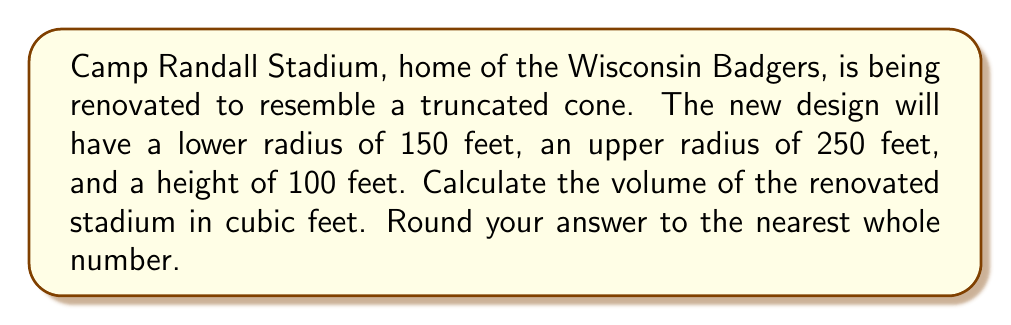Show me your answer to this math problem. To solve this problem, we'll use the formula for the volume of a truncated cone:

$$V = \frac{1}{3}\pi h(R^2 + r^2 + Rr)$$

Where:
$V$ = volume
$h$ = height
$R$ = radius of the larger base
$r$ = radius of the smaller base

Given:
$h = 100$ feet
$R = 250$ feet
$r = 150$ feet

Let's substitute these values into the formula:

$$V = \frac{1}{3}\pi \cdot 100(250^2 + 150^2 + 250 \cdot 150)$$

Now, let's calculate step by step:

1) First, calculate the squares:
   $250^2 = 62,500$
   $150^2 = 22,500$

2) Calculate the product:
   $250 \cdot 150 = 37,500$

3) Sum these values:
   $62,500 + 22,500 + 37,500 = 122,500$

4) Multiply by $h = 100$:
   $100 \cdot 122,500 = 12,250,000$

5) Multiply by $\frac{1}{3}\pi$:
   $\frac{1}{3}\pi \cdot 12,250,000 \approx 12,829,183.47$

6) Round to the nearest whole number:
   $12,829,183$

Therefore, the volume of the renovated Camp Randall Stadium would be approximately 12,829,183 cubic feet.
Answer: $12,829,183$ cubic feet 